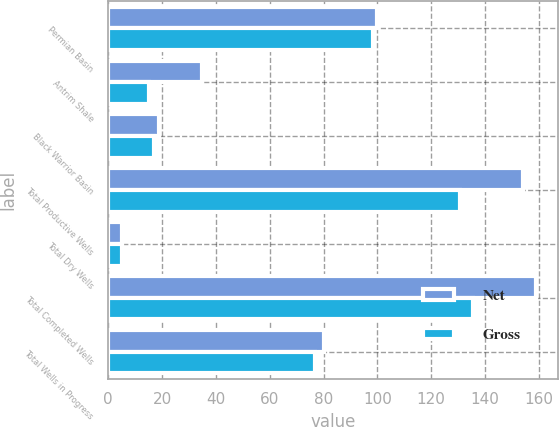Convert chart to OTSL. <chart><loc_0><loc_0><loc_500><loc_500><stacked_bar_chart><ecel><fcel>Permian Basin<fcel>Antrim Shale<fcel>Black Warrior Basin<fcel>Total Productive Wells<fcel>Total Dry Wells<fcel>Total Completed Wells<fcel>Total Wells in Progress<nl><fcel>Net<fcel>100<fcel>35<fcel>19<fcel>154<fcel>5<fcel>159<fcel>80<nl><fcel>Gross<fcel>98.5<fcel>15.1<fcel>17.1<fcel>130.7<fcel>5<fcel>135.7<fcel>76.9<nl></chart> 